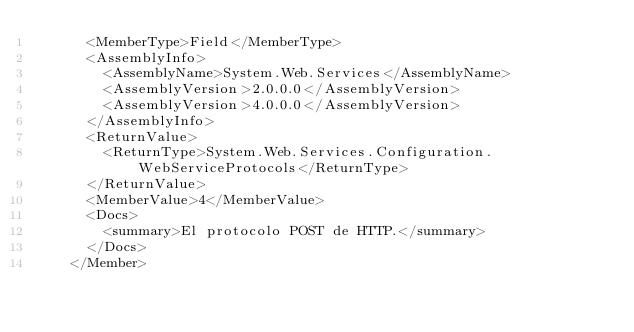Convert code to text. <code><loc_0><loc_0><loc_500><loc_500><_XML_>      <MemberType>Field</MemberType>
      <AssemblyInfo>
        <AssemblyName>System.Web.Services</AssemblyName>
        <AssemblyVersion>2.0.0.0</AssemblyVersion>
        <AssemblyVersion>4.0.0.0</AssemblyVersion>
      </AssemblyInfo>
      <ReturnValue>
        <ReturnType>System.Web.Services.Configuration.WebServiceProtocols</ReturnType>
      </ReturnValue>
      <MemberValue>4</MemberValue>
      <Docs>
        <summary>El protocolo POST de HTTP.</summary>
      </Docs>
    </Member></code> 